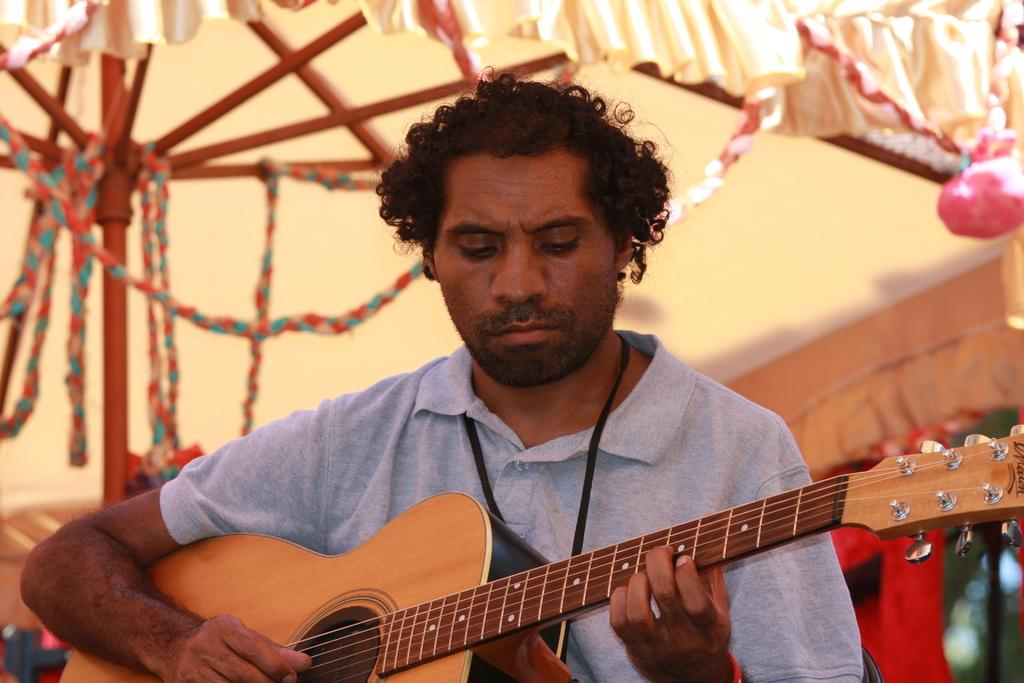What is the man in the image doing? The man is playing a guitar in the image. What object is present in the image that is typically used for shelter? There is a tent in the image. What type of stem can be seen growing from the guitar in the image? There is no stem growing from the guitar in the image; it is a musical instrument. 